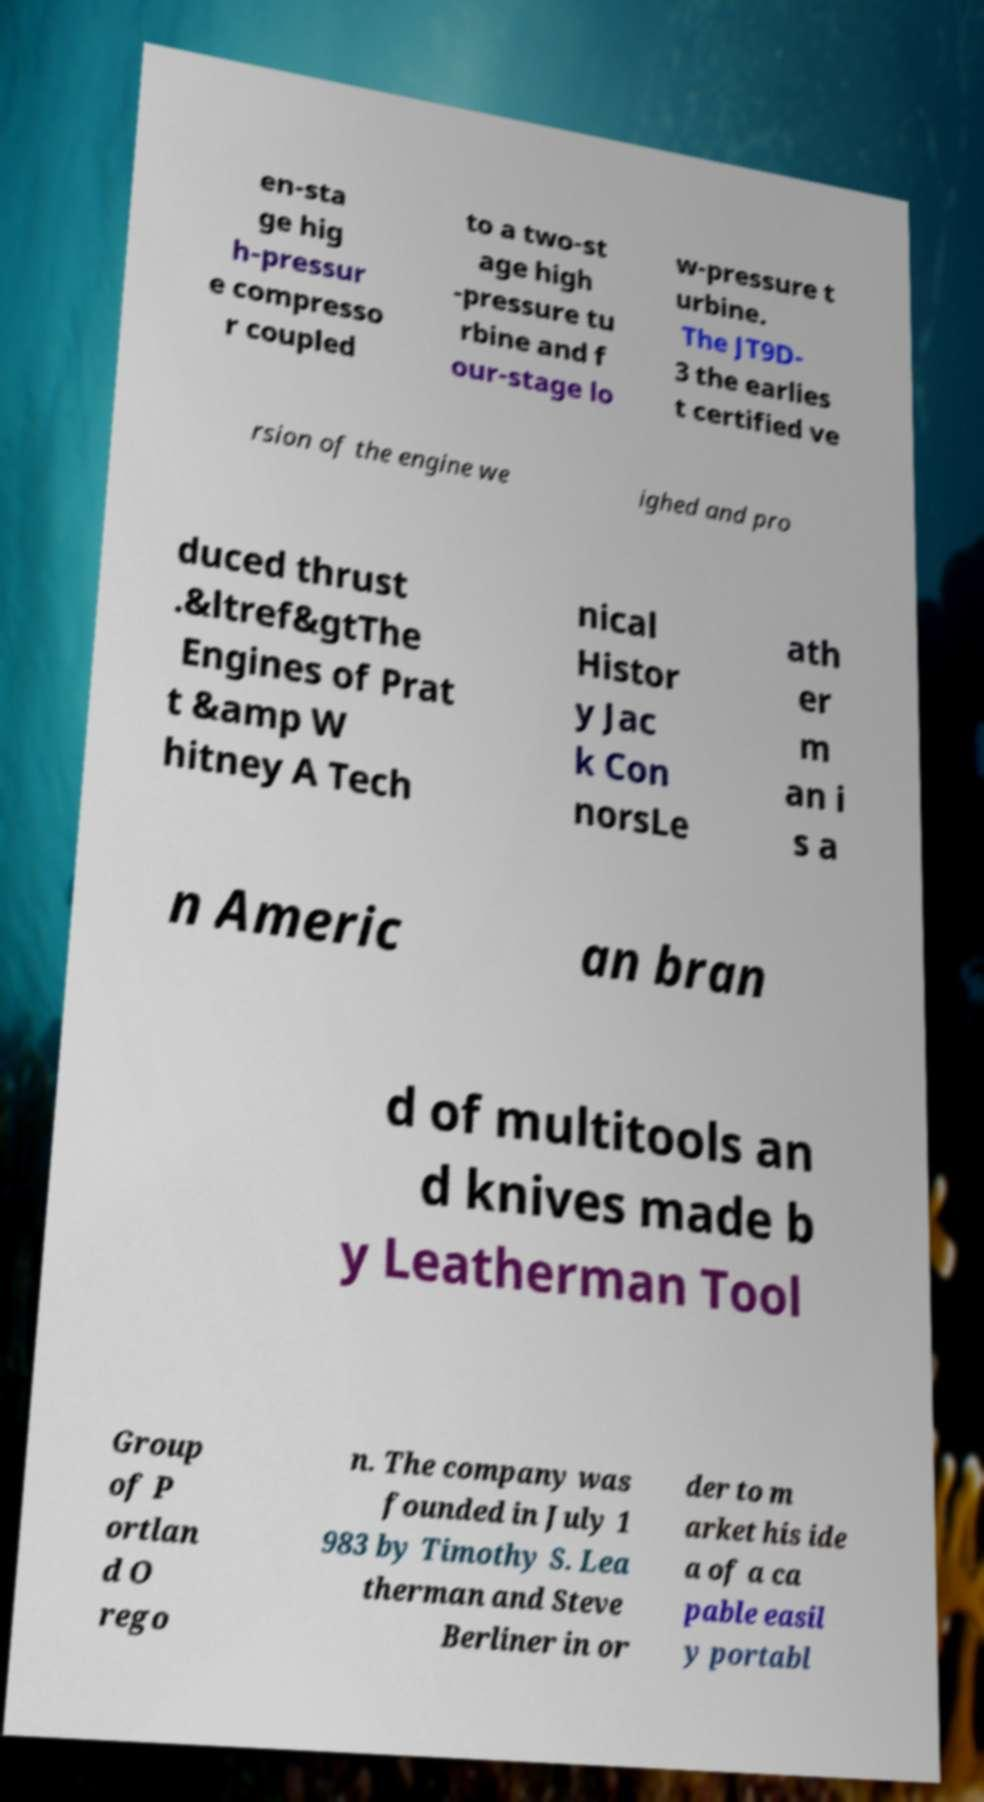What messages or text are displayed in this image? I need them in a readable, typed format. en-sta ge hig h-pressur e compresso r coupled to a two-st age high -pressure tu rbine and f our-stage lo w-pressure t urbine. The JT9D- 3 the earlies t certified ve rsion of the engine we ighed and pro duced thrust .&ltref&gtThe Engines of Prat t &amp W hitney A Tech nical Histor y Jac k Con norsLe ath er m an i s a n Americ an bran d of multitools an d knives made b y Leatherman Tool Group of P ortlan d O rego n. The company was founded in July 1 983 by Timothy S. Lea therman and Steve Berliner in or der to m arket his ide a of a ca pable easil y portabl 